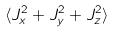<formula> <loc_0><loc_0><loc_500><loc_500>\langle J _ { x } ^ { 2 } + J _ { y } ^ { 2 } + J _ { z } ^ { 2 } \rangle</formula> 